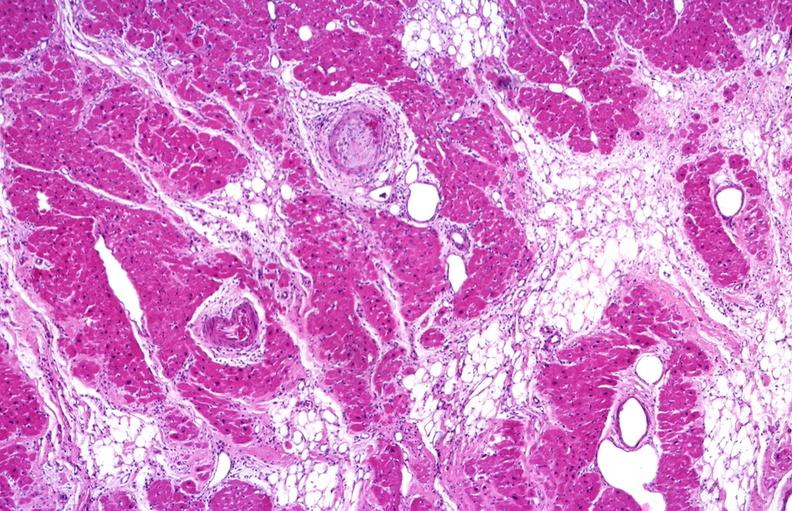does this image show heart, polyarteritis nodosa?
Answer the question using a single word or phrase. Yes 